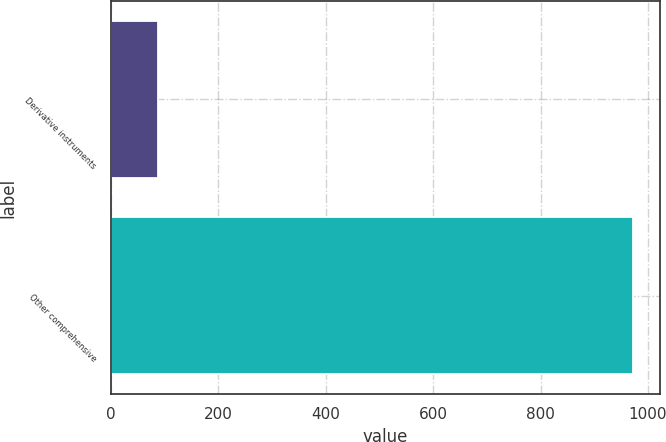Convert chart. <chart><loc_0><loc_0><loc_500><loc_500><bar_chart><fcel>Derivative instruments<fcel>Other comprehensive<nl><fcel>87<fcel>973<nl></chart> 